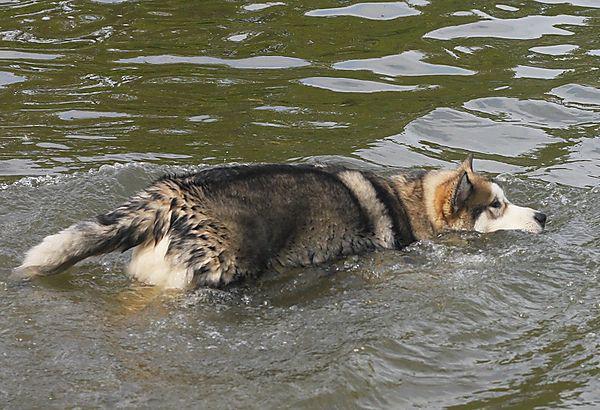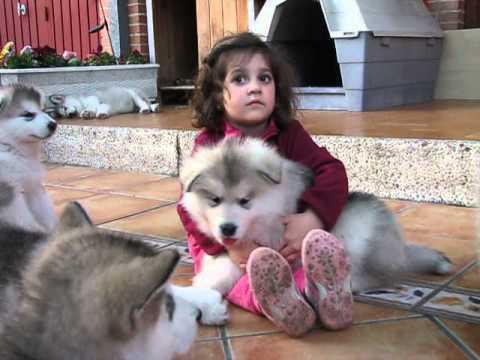The first image is the image on the left, the second image is the image on the right. Assess this claim about the two images: "The left image contains no more than one dog.". Correct or not? Answer yes or no. Yes. The first image is the image on the left, the second image is the image on the right. Assess this claim about the two images: "A dark-haired girl has her arms around at least one dog in one image, and the other image shows just one dog that is not interacting.". Correct or not? Answer yes or no. Yes. 